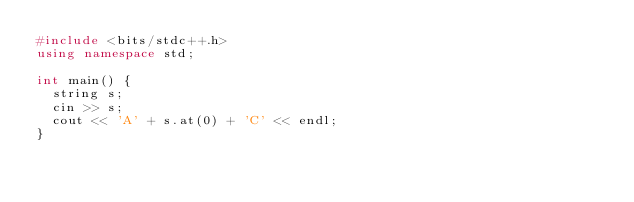<code> <loc_0><loc_0><loc_500><loc_500><_C++_>#include <bits/stdc++.h>
using namespace std;

int main() {
  string s;
  cin >> s;
  cout << 'A' + s.at(0) + 'C' << endl;
}</code> 